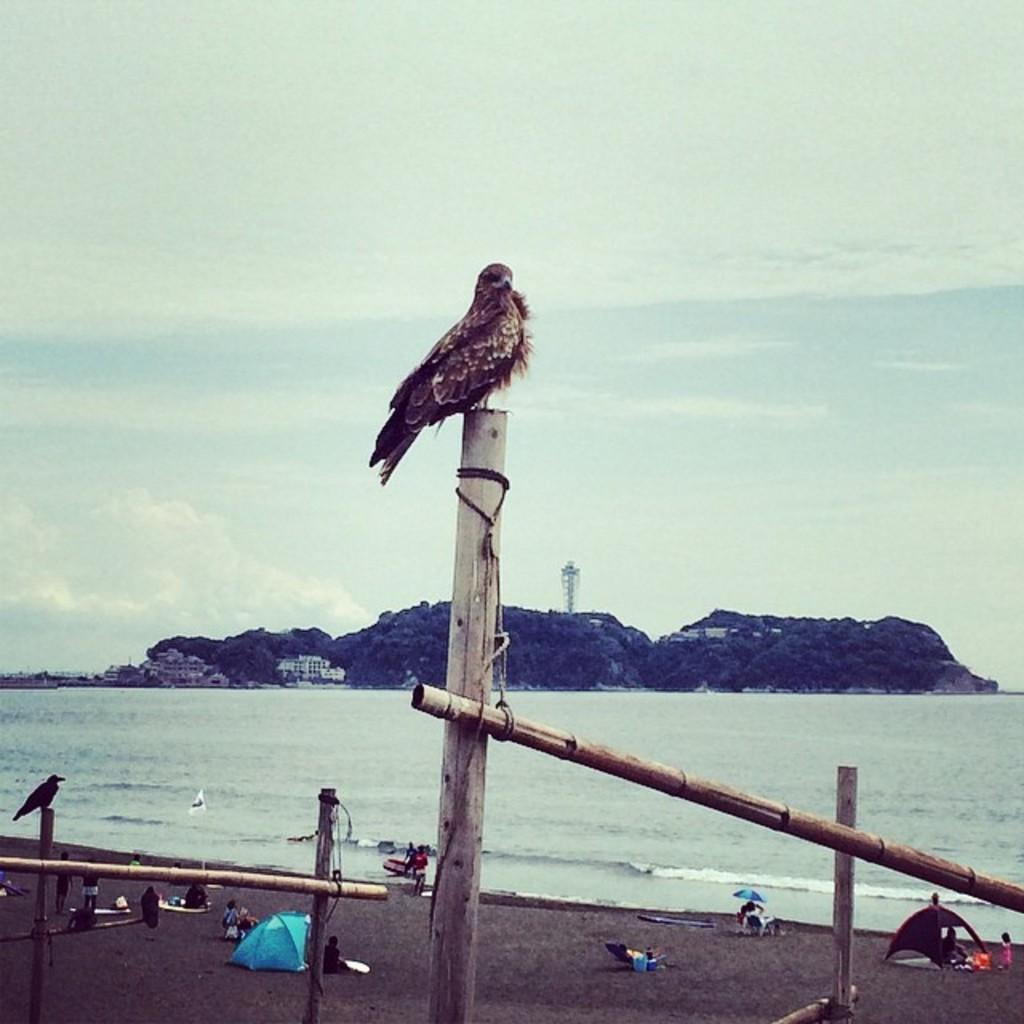Please provide a concise description of this image. In this image we can see the lake, mountains, some objects on the mountains, one antenna, two objects near the mountains looks like boats, some objects near the mountains on the left side of the image, one flag with pole, some objects on the ground, some objects in the water, one umbrella, two tents, some wooden poles with threads, some people are sitting, few people are standing, few people are walking, one girl standing on the right side of the image, two birds on the wooden poles and at the top there is the cloudy sky. 